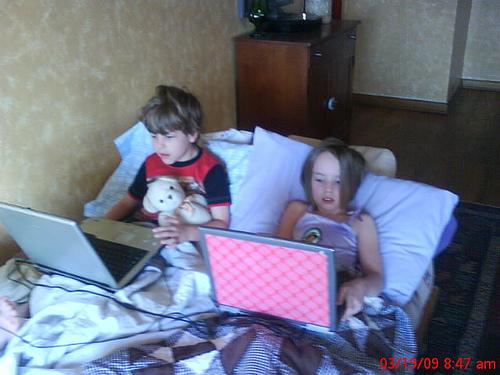What color is the girls computer?
Keep it brief. Pink. What race is the child?
Short answer required. White. Are these two people married to each other?
Give a very brief answer. No. What is the boy holding beneath his arm?
Be succinct. Teddy bear. 